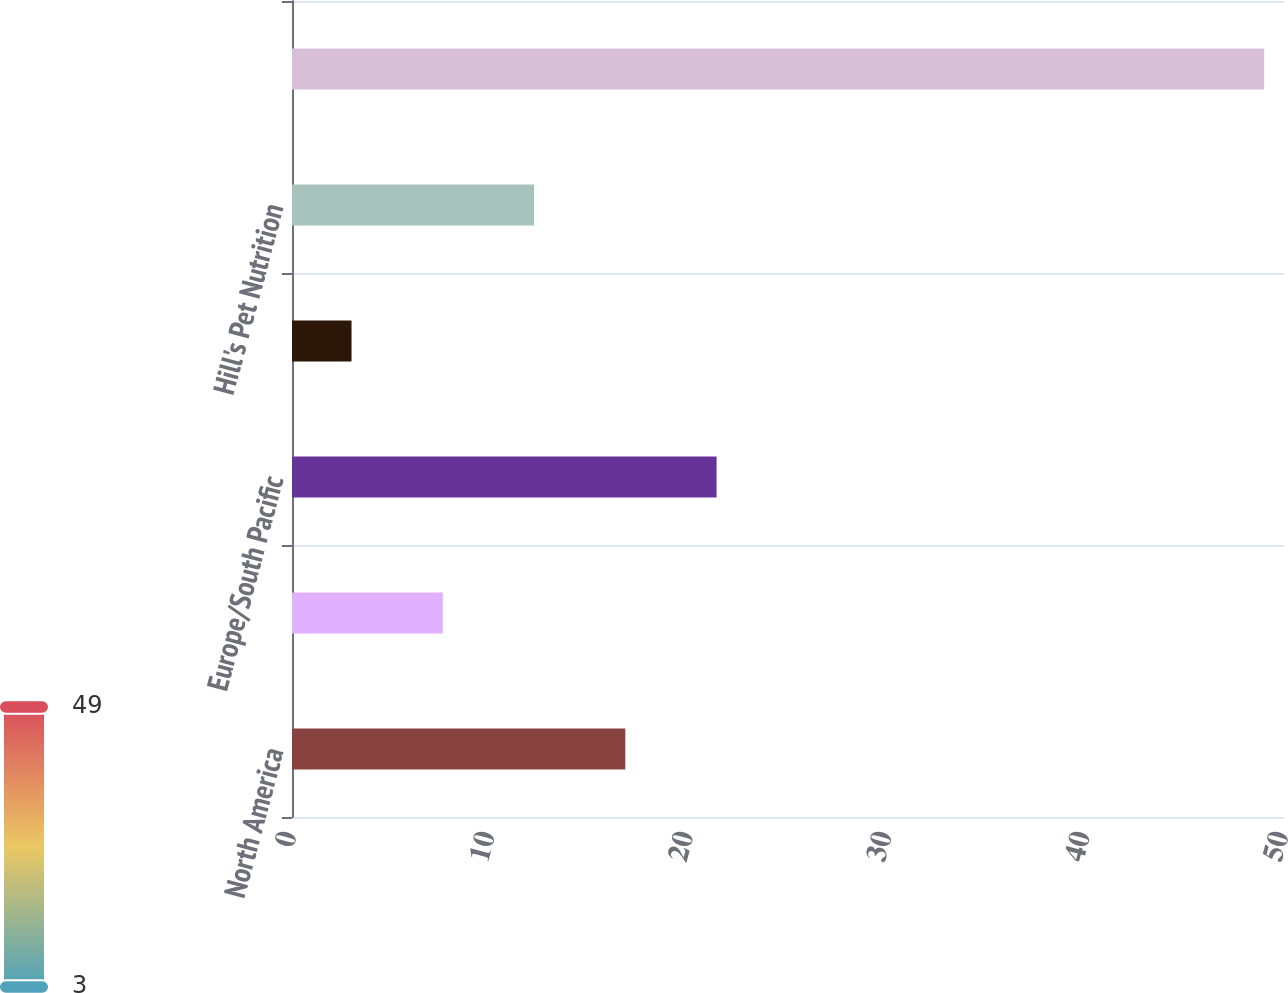<chart> <loc_0><loc_0><loc_500><loc_500><bar_chart><fcel>North America<fcel>Latin America<fcel>Europe/South Pacific<fcel>Africa/Eurasia<fcel>Hill's Pet Nutrition<fcel>Corporate<nl><fcel>16.8<fcel>7.6<fcel>21.4<fcel>3<fcel>12.2<fcel>49<nl></chart> 